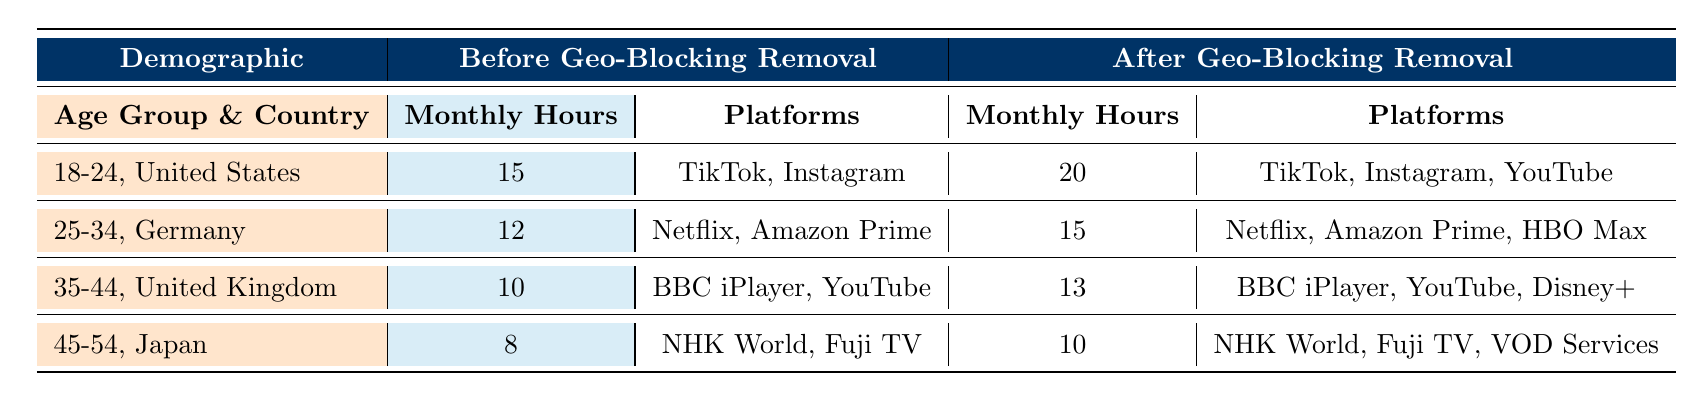What was the most popular content type among 25-34-year-olds in Germany before geo-blocking removal? Before geo-blocking was removed, the most popular content type among 25-34-year-olds in Germany was "TV Shows," as stated in the table under that demographic segment.
Answer: TV Shows How many monthly hours did the 18-24 age group from the United States spend streaming after geo-blocking removal? After geo-blocking removal, the monthly hours spent streaming by the 18-24 age group in the United States increased to 20, as indicated in the corresponding row of the table.
Answer: 20 Which demographic segment had the least monthly streaming hours before geo-blocking removal? By comparing the monthly hours of streaming for all groups before geo-blocking removal, the 45-54 age group from Japan had the least, with 8 monthly hours.
Answer: 45-54, Japan What is the increase in monthly streaming hours for the 35-44 age group from the United Kingdom after geo-blocking removal? The 35-44 age group from the United Kingdom had monthly streaming hours of 10 before geo-blocking removal and jumped to 13 after, resulting in an increase of 3 hours (13 - 10 = 3).
Answer: 3 Did the 45-54 age group in Japan have a change in their popular content type after geo-blocking removal? Yes, before geo-blocking removal, their popular content type was "News," and after it changed to "News and Entertainment," which indicates a shift in content preference.
Answer: Yes What was the average monthly streaming hours across all age groups in the United States before geo-blocking removal? The average monthly streaming hours in the United States across the 18-24 age group is 15 hours. Since this is the only data available for the U.S. in the table, it remains 15.
Answer: 15 Which preferred platforms for the 25-34 age group in Germany increased after geo-blocking removal? Initially, the preferred platforms for this group were "Netflix" and "Amazon Prime." After the geo-blocking removal, "HBO Max" was added, indicating an increase in platform options.
Answer: HBO Max How many more preferred platforms does the 18-24 age group from the United States have after geo-blocking removal compared to before? The 18-24 age group had 2 preferred platforms (TikTok, Instagram) before geo-blocking removal and added YouTube after, resulting in a total of 3. So, they have 1 more preferred platform (3 - 2 = 1) after geo-blocking removal.
Answer: 1 Is the total number of monthly hours for all demographic segments higher before or after geo-blocking removal? Before geo-blocking removal, the total monthly hours were 45 (15 + 12 + 10 + 8). After geo-blocking removal, the total is 58 (20 + 15 + 13 + 10). Thus, the total is higher after geo-blocking removal (58 > 45).
Answer: After geo-blocking removal 